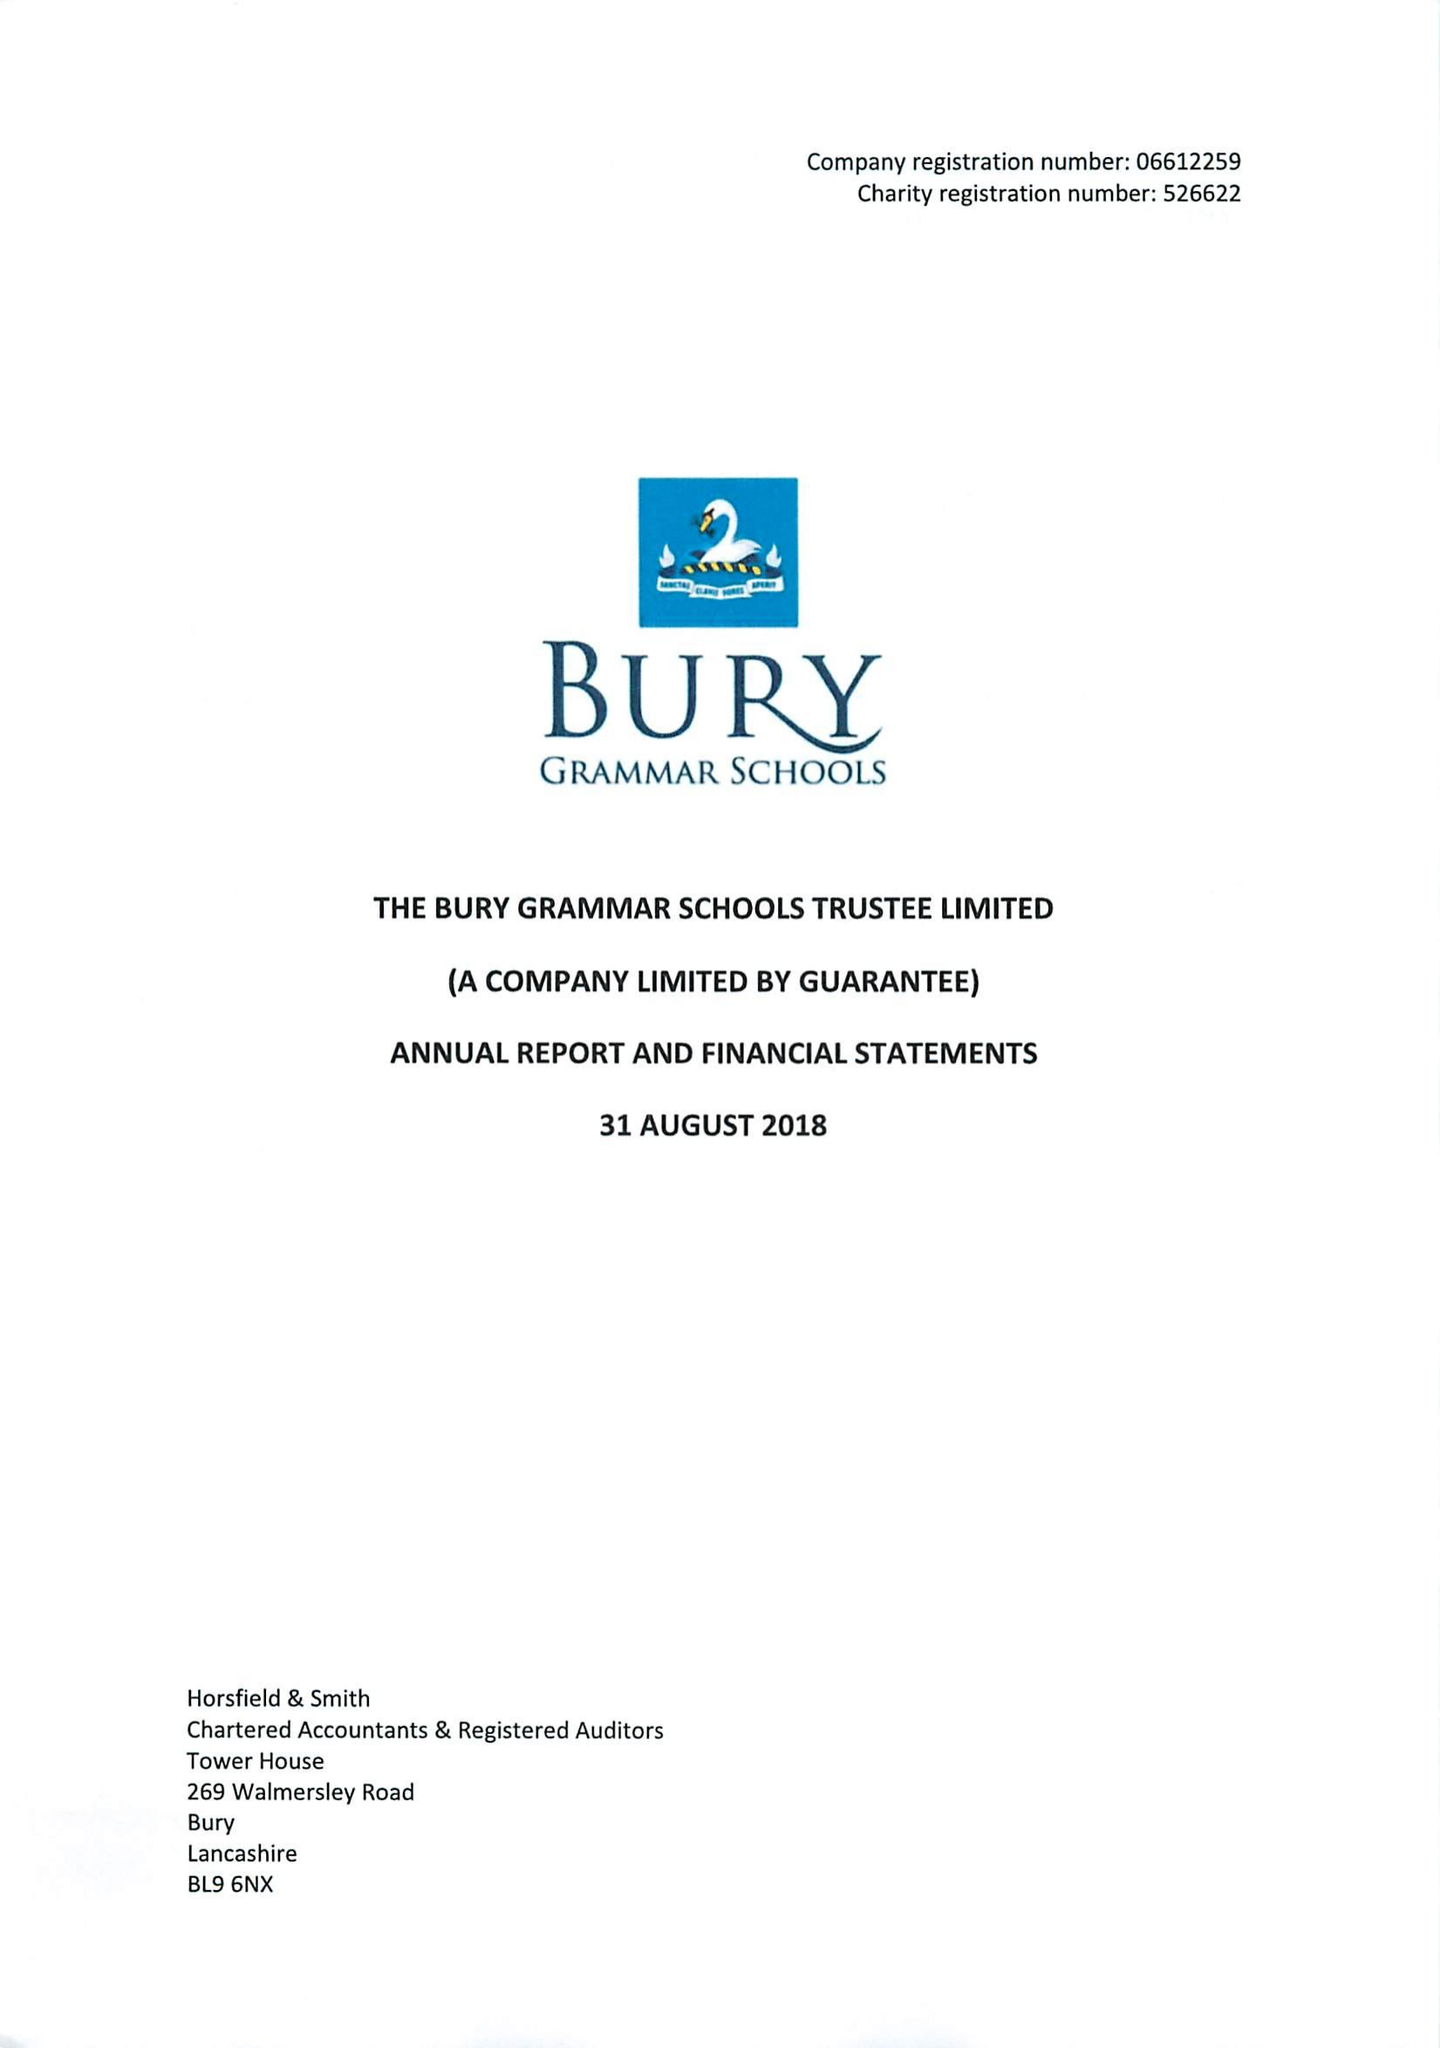What is the value for the address__post_town?
Answer the question using a single word or phrase. BURY 